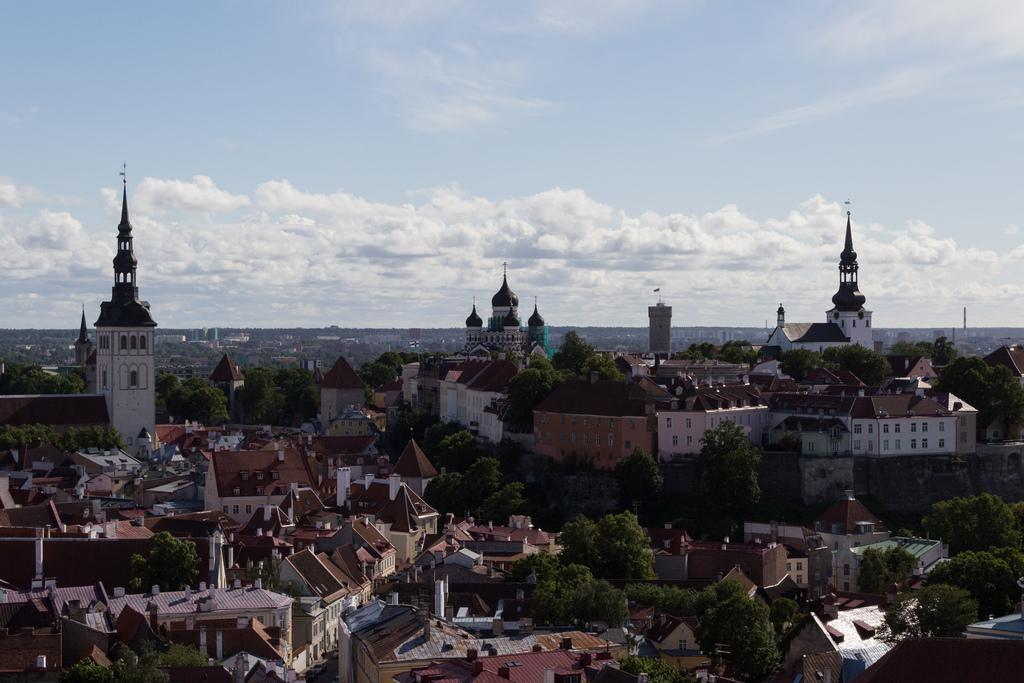What type of structures can be seen in the image? There are buildings in the image. What other natural elements are present in the image? There are trees in the image. What part of the natural environment is visible in the image? The sky is visible in the image. What can be observed in the sky? Clouds are present in the sky. What type of glove is being used to perform an action in the image? There is no glove or action being performed in the image; it only features buildings, trees, sky, and clouds. 